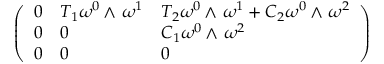<formula> <loc_0><loc_0><loc_500><loc_500>\left ( \begin{array} { l l l } { 0 } & { T _ { 1 } \omega ^ { 0 } { \, { \wedge } \, } \omega ^ { 1 } } & { T _ { 2 } \omega ^ { 0 } { \, { \wedge } \, } \omega ^ { 1 } + C _ { 2 } \omega ^ { 0 } { \, { \wedge } \, } \omega ^ { 2 } } \\ { 0 } & { 0 } & { C _ { 1 } \omega ^ { 0 } { \, { \wedge } \, } \omega ^ { 2 } } \\ { 0 } & { 0 } & { 0 } \end{array} \right )</formula> 